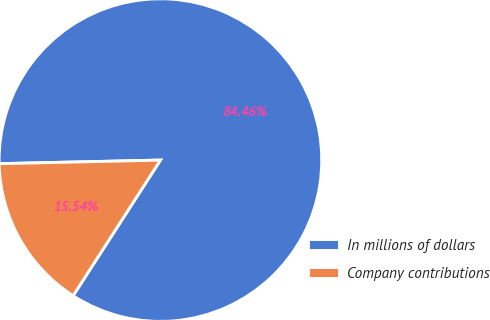Convert chart. <chart><loc_0><loc_0><loc_500><loc_500><pie_chart><fcel>In millions of dollars<fcel>Company contributions<nl><fcel>84.46%<fcel>15.54%<nl></chart> 